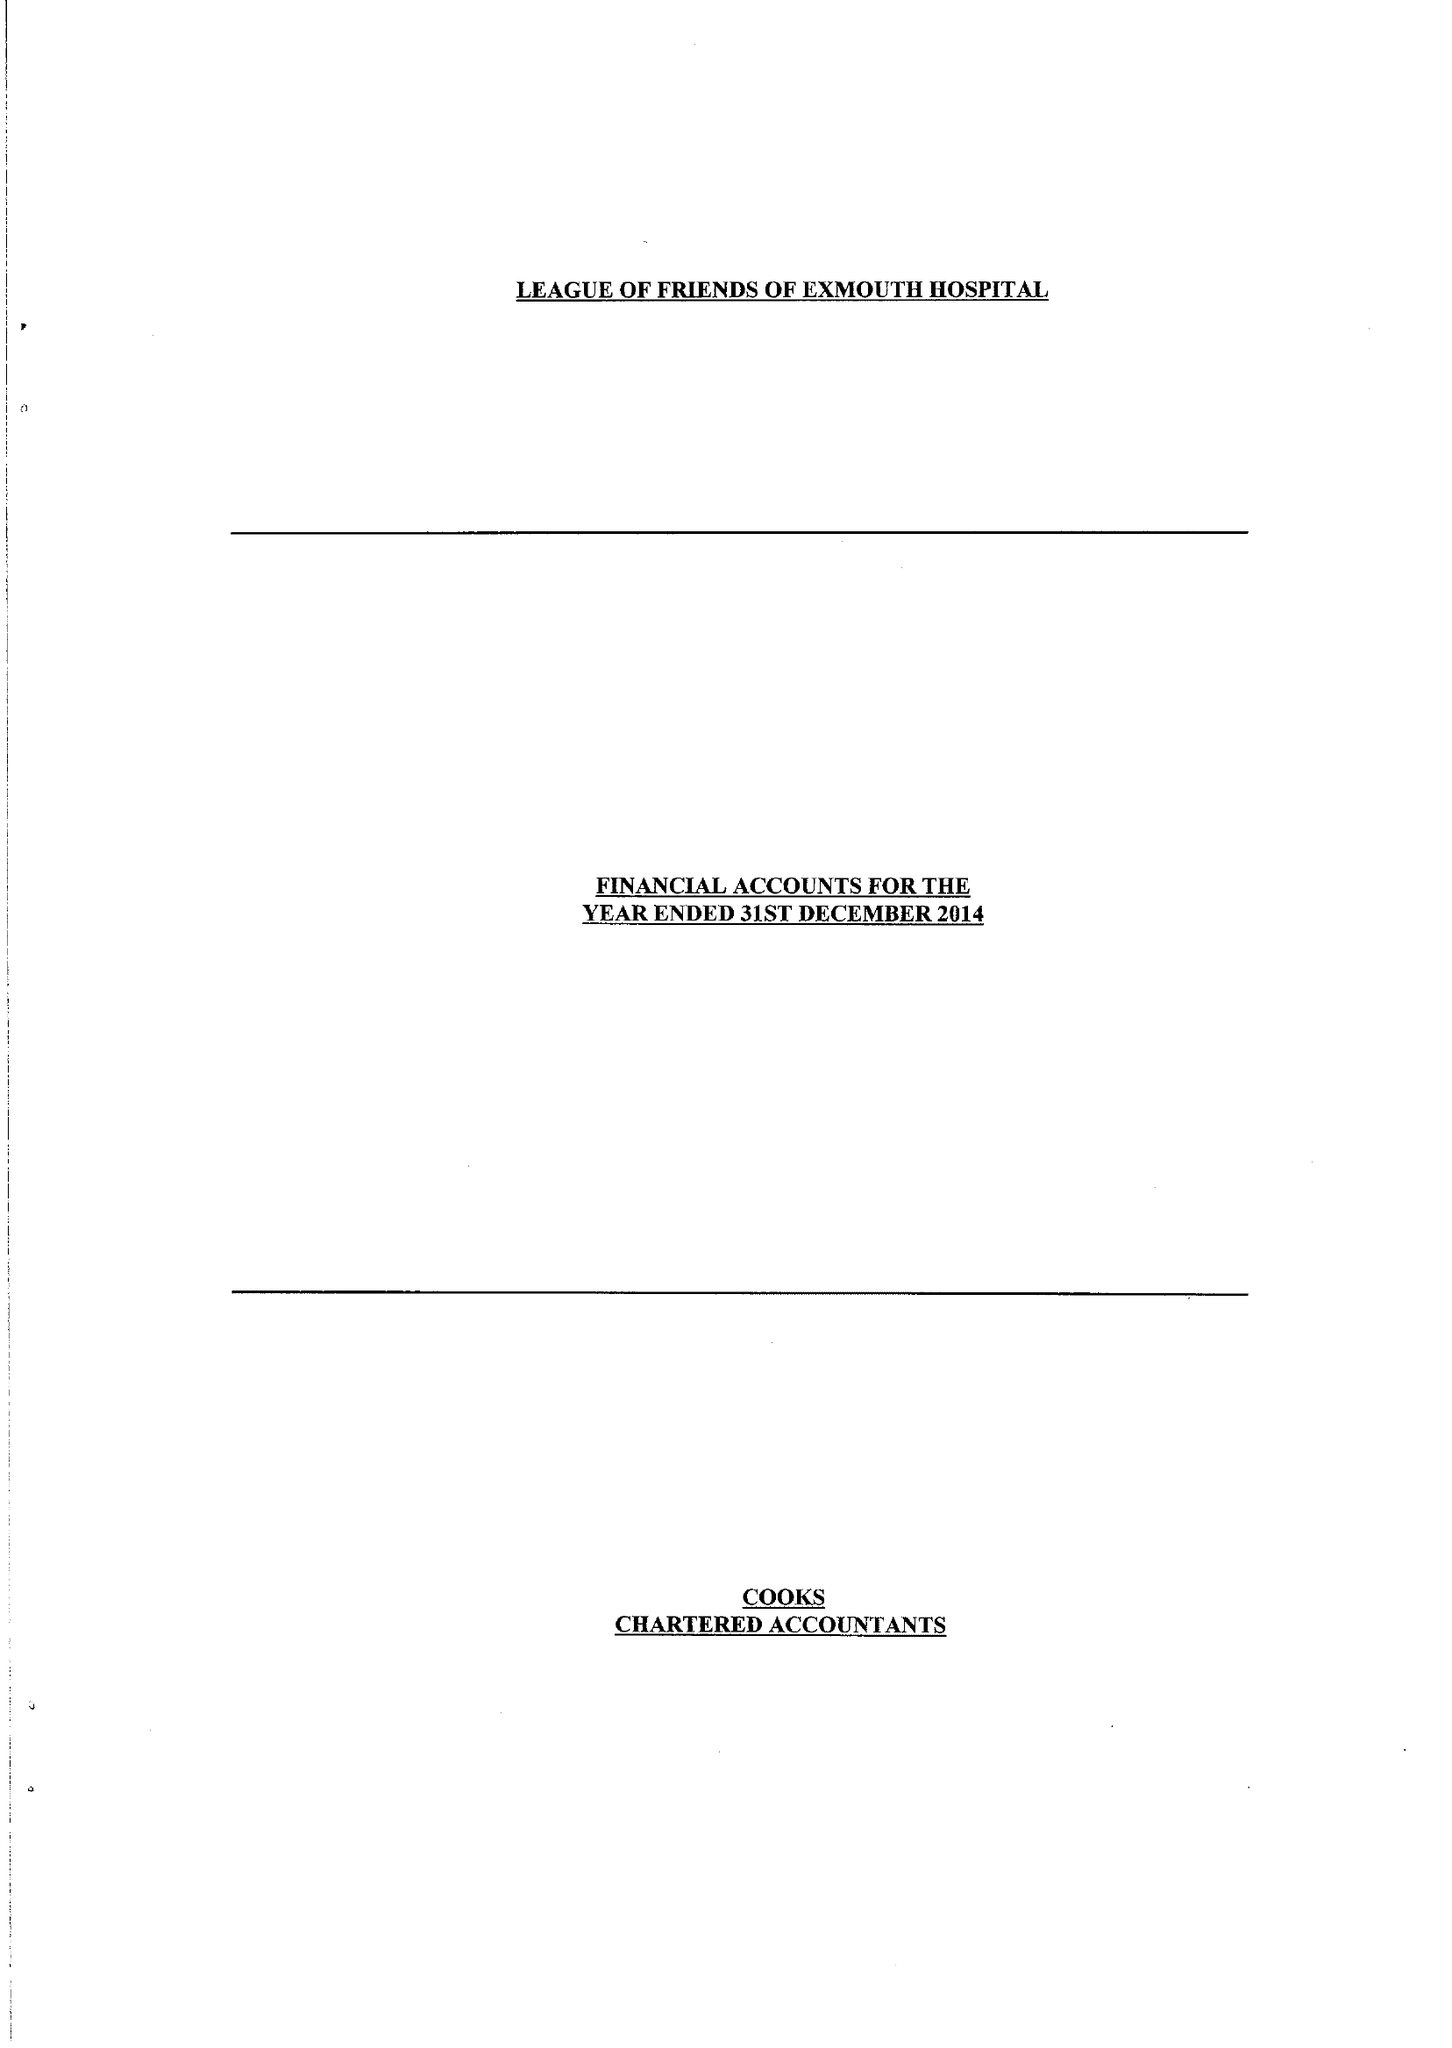What is the value for the spending_annually_in_british_pounds?
Answer the question using a single word or phrase. 25683.00 